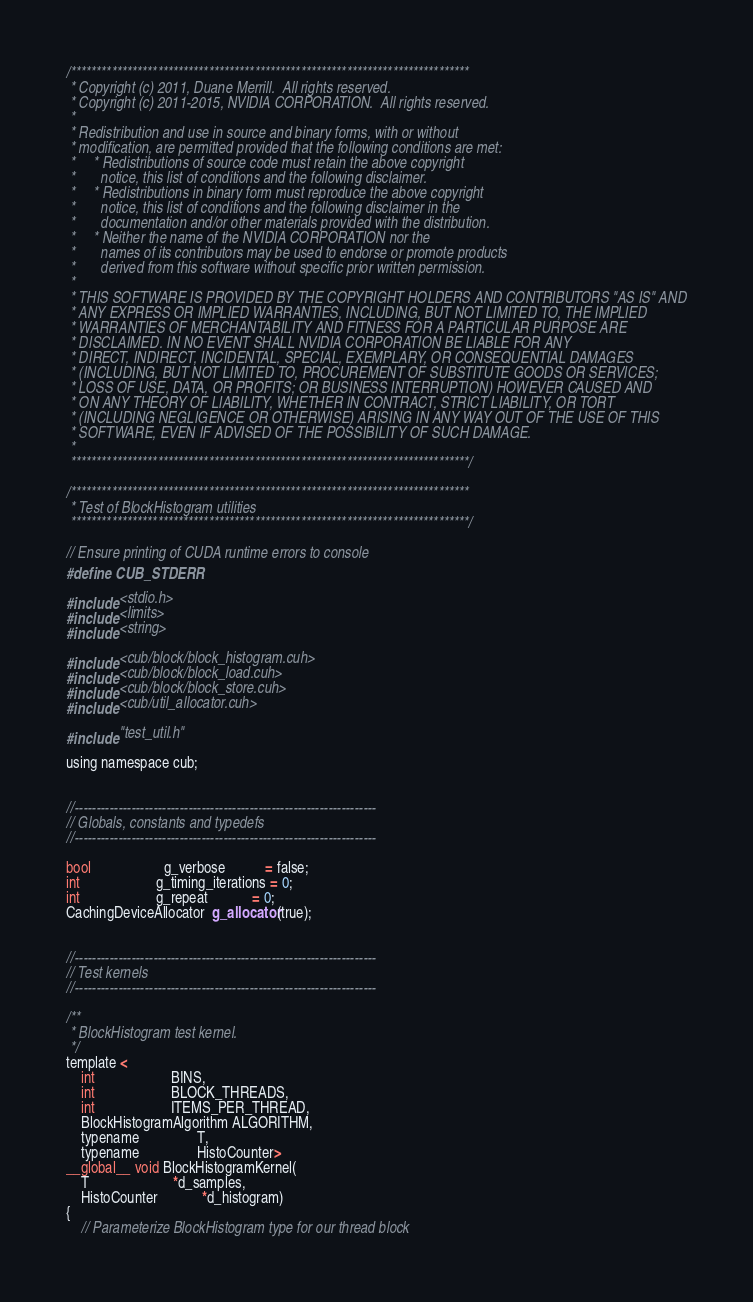Convert code to text. <code><loc_0><loc_0><loc_500><loc_500><_Cuda_>/******************************************************************************
 * Copyright (c) 2011, Duane Merrill.  All rights reserved.
 * Copyright (c) 2011-2015, NVIDIA CORPORATION.  All rights reserved.
 *
 * Redistribution and use in source and binary forms, with or without
 * modification, are permitted provided that the following conditions are met:
 *     * Redistributions of source code must retain the above copyright
 *       notice, this list of conditions and the following disclaimer.
 *     * Redistributions in binary form must reproduce the above copyright
 *       notice, this list of conditions and the following disclaimer in the
 *       documentation and/or other materials provided with the distribution.
 *     * Neither the name of the NVIDIA CORPORATION nor the
 *       names of its contributors may be used to endorse or promote products
 *       derived from this software without specific prior written permission.
 *
 * THIS SOFTWARE IS PROVIDED BY THE COPYRIGHT HOLDERS AND CONTRIBUTORS "AS IS" AND
 * ANY EXPRESS OR IMPLIED WARRANTIES, INCLUDING, BUT NOT LIMITED TO, THE IMPLIED
 * WARRANTIES OF MERCHANTABILITY AND FITNESS FOR A PARTICULAR PURPOSE ARE
 * DISCLAIMED. IN NO EVENT SHALL NVIDIA CORPORATION BE LIABLE FOR ANY
 * DIRECT, INDIRECT, INCIDENTAL, SPECIAL, EXEMPLARY, OR CONSEQUENTIAL DAMAGES
 * (INCLUDING, BUT NOT LIMITED TO, PROCUREMENT OF SUBSTITUTE GOODS OR SERVICES;
 * LOSS OF USE, DATA, OR PROFITS; OR BUSINESS INTERRUPTION) HOWEVER CAUSED AND
 * ON ANY THEORY OF LIABILITY, WHETHER IN CONTRACT, STRICT LIABILITY, OR TORT
 * (INCLUDING NEGLIGENCE OR OTHERWISE) ARISING IN ANY WAY OUT OF THE USE OF THIS
 * SOFTWARE, EVEN IF ADVISED OF THE POSSIBILITY OF SUCH DAMAGE.
 *
 ******************************************************************************/

/******************************************************************************
 * Test of BlockHistogram utilities
 ******************************************************************************/

// Ensure printing of CUDA runtime errors to console
#define CUB_STDERR

#include <stdio.h>
#include <limits>
#include <string>

#include <cub/block/block_histogram.cuh>
#include <cub/block/block_load.cuh>
#include <cub/block/block_store.cuh>
#include <cub/util_allocator.cuh>

#include "test_util.h"

using namespace cub;


//---------------------------------------------------------------------
// Globals, constants and typedefs
//---------------------------------------------------------------------

bool                    g_verbose           = false;
int                     g_timing_iterations = 0;
int                     g_repeat            = 0;
CachingDeviceAllocator  g_allocator(true);


//---------------------------------------------------------------------
// Test kernels
//---------------------------------------------------------------------

/**
 * BlockHistogram test kernel.
 */
template <
    int                     BINS,
    int                     BLOCK_THREADS,
    int                     ITEMS_PER_THREAD,
    BlockHistogramAlgorithm ALGORITHM,
    typename                T,
    typename                HistoCounter>
__global__ void BlockHistogramKernel(
    T                       *d_samples,
    HistoCounter            *d_histogram)
{
    // Parameterize BlockHistogram type for our thread block</code> 